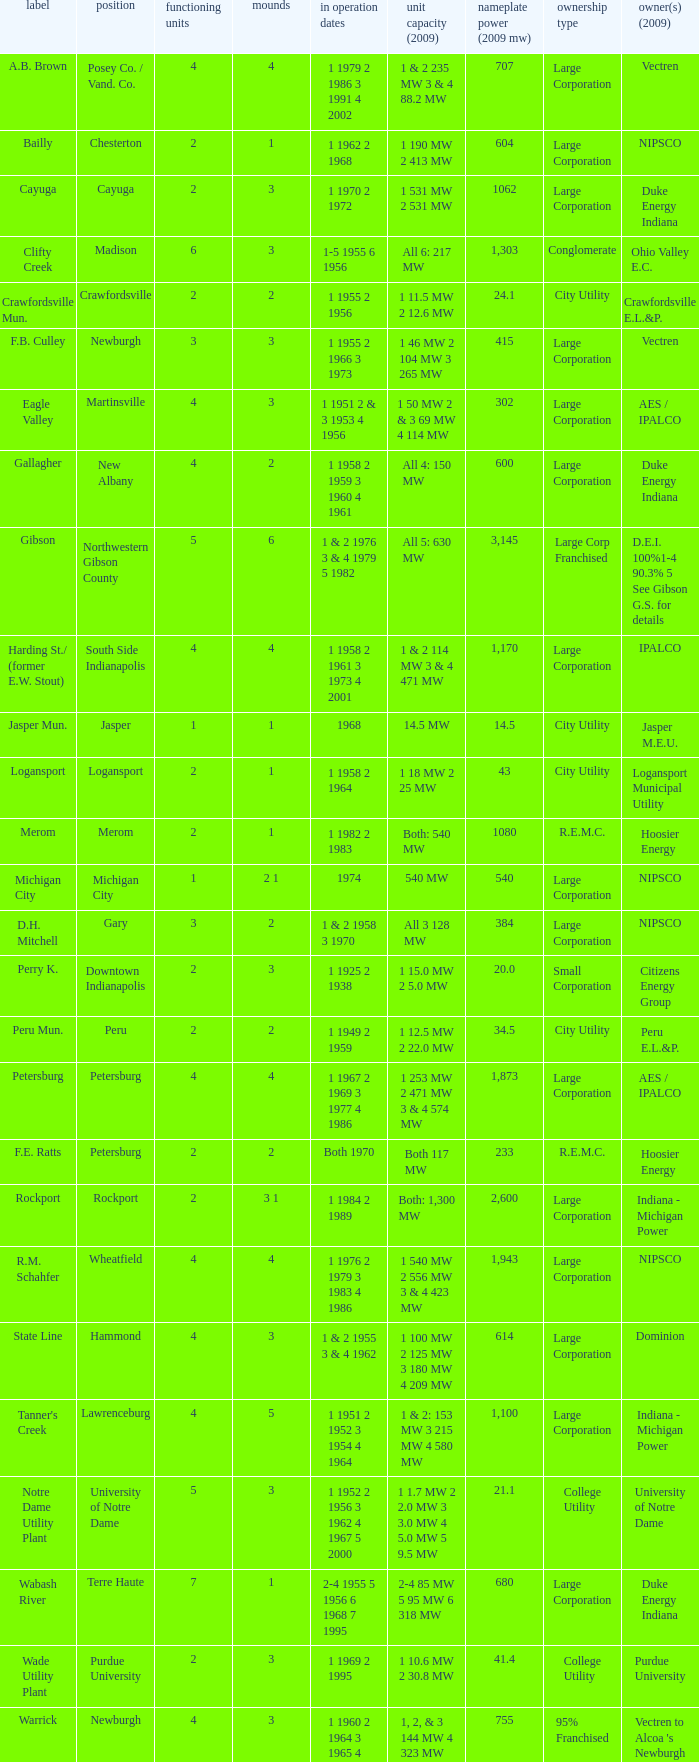Name the number for service dates for hoosier energy for petersburg 1.0. 